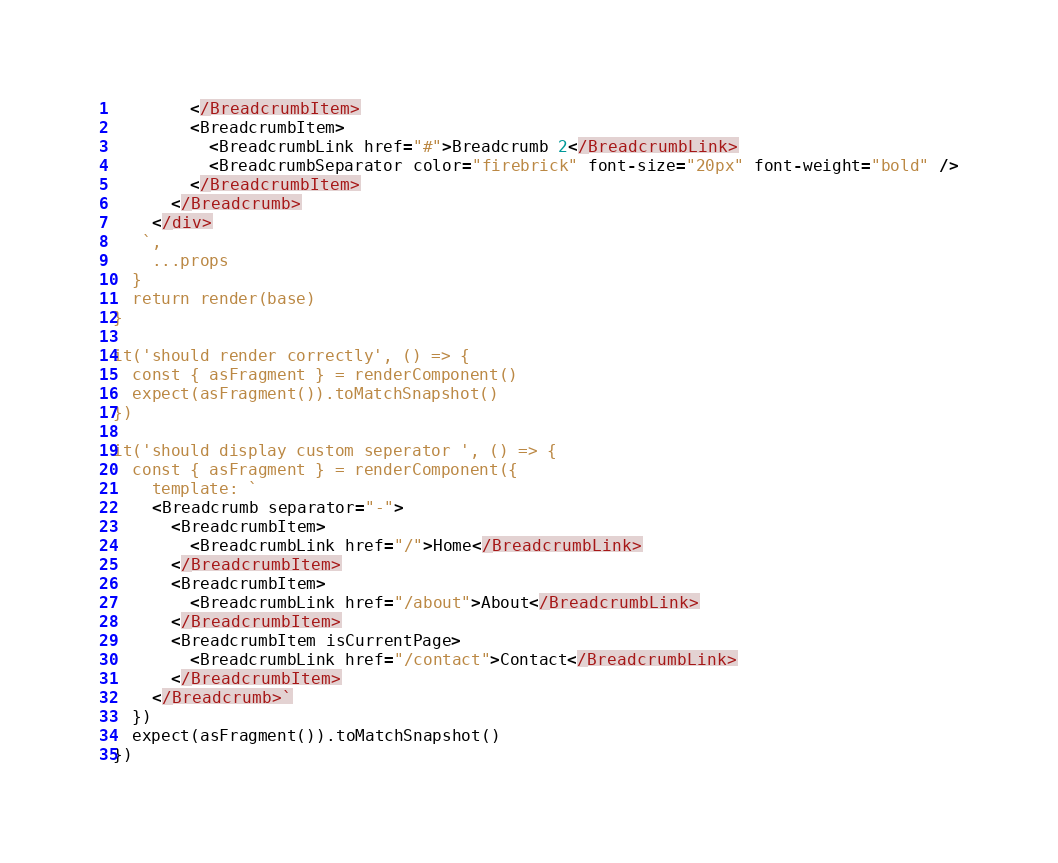<code> <loc_0><loc_0><loc_500><loc_500><_JavaScript_>        </BreadcrumbItem>
        <BreadcrumbItem>
          <BreadcrumbLink href="#">Breadcrumb 2</BreadcrumbLink>
          <BreadcrumbSeparator color="firebrick" font-size="20px" font-weight="bold" />
        </BreadcrumbItem>
      </Breadcrumb>
    </div>
   `,
    ...props
  }
  return render(base)
}

it('should render correctly', () => {
  const { asFragment } = renderComponent()
  expect(asFragment()).toMatchSnapshot()
})

it('should display custom seperator ', () => {
  const { asFragment } = renderComponent({
    template: `
    <Breadcrumb separator="-">
      <BreadcrumbItem>
        <BreadcrumbLink href="/">Home</BreadcrumbLink>
      </BreadcrumbItem>
      <BreadcrumbItem>
        <BreadcrumbLink href="/about">About</BreadcrumbLink>
      </BreadcrumbItem>
      <BreadcrumbItem isCurrentPage>
        <BreadcrumbLink href="/contact">Contact</BreadcrumbLink>
      </BreadcrumbItem>
    </Breadcrumb>`
  })
  expect(asFragment()).toMatchSnapshot()
})
</code> 